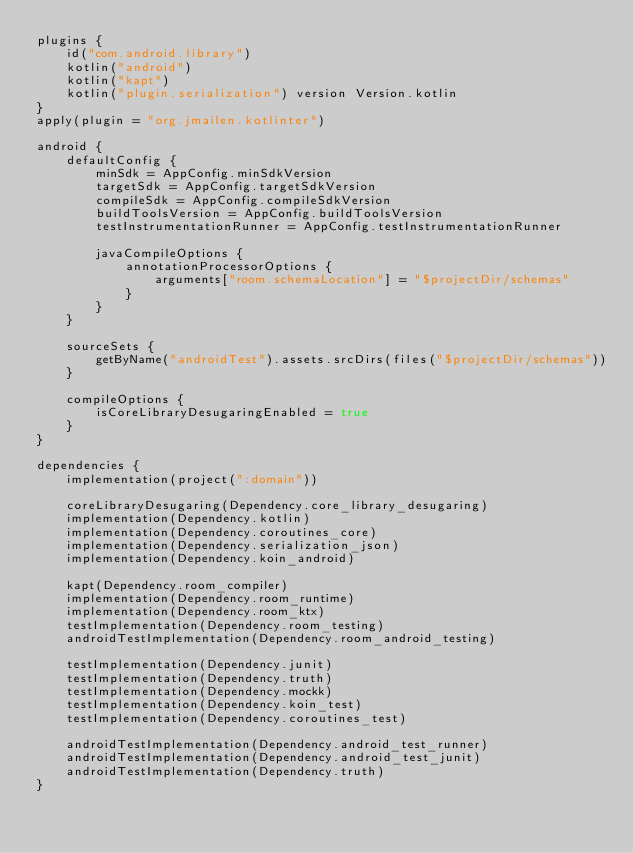Convert code to text. <code><loc_0><loc_0><loc_500><loc_500><_Kotlin_>plugins {
    id("com.android.library")
    kotlin("android")
    kotlin("kapt")
    kotlin("plugin.serialization") version Version.kotlin
}
apply(plugin = "org.jmailen.kotlinter")

android {
    defaultConfig {
        minSdk = AppConfig.minSdkVersion
        targetSdk = AppConfig.targetSdkVersion
        compileSdk = AppConfig.compileSdkVersion
        buildToolsVersion = AppConfig.buildToolsVersion
        testInstrumentationRunner = AppConfig.testInstrumentationRunner

        javaCompileOptions {
            annotationProcessorOptions {
                arguments["room.schemaLocation"] = "$projectDir/schemas"
            }
        }
    }

    sourceSets {
        getByName("androidTest").assets.srcDirs(files("$projectDir/schemas"))
    }

    compileOptions {
        isCoreLibraryDesugaringEnabled = true
    }
}

dependencies {
    implementation(project(":domain"))

    coreLibraryDesugaring(Dependency.core_library_desugaring)
    implementation(Dependency.kotlin)
    implementation(Dependency.coroutines_core)
    implementation(Dependency.serialization_json)
    implementation(Dependency.koin_android)

    kapt(Dependency.room_compiler)
    implementation(Dependency.room_runtime)
    implementation(Dependency.room_ktx)
    testImplementation(Dependency.room_testing)
    androidTestImplementation(Dependency.room_android_testing)

    testImplementation(Dependency.junit)
    testImplementation(Dependency.truth)
    testImplementation(Dependency.mockk)
    testImplementation(Dependency.koin_test)
    testImplementation(Dependency.coroutines_test)

    androidTestImplementation(Dependency.android_test_runner)
    androidTestImplementation(Dependency.android_test_junit)
    androidTestImplementation(Dependency.truth)
}</code> 